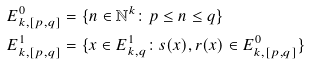<formula> <loc_0><loc_0><loc_500><loc_500>& E _ { k , [ p , q ] } ^ { 0 } = \{ n \in \mathbb { N } ^ { k } \colon p \leq n \leq q \} \\ & E _ { k , [ p , q ] } ^ { 1 } = \{ x \in E _ { k , q } ^ { 1 } \colon s ( x ) , r ( x ) \in E _ { k , [ p , q ] } ^ { 0 } \}</formula> 